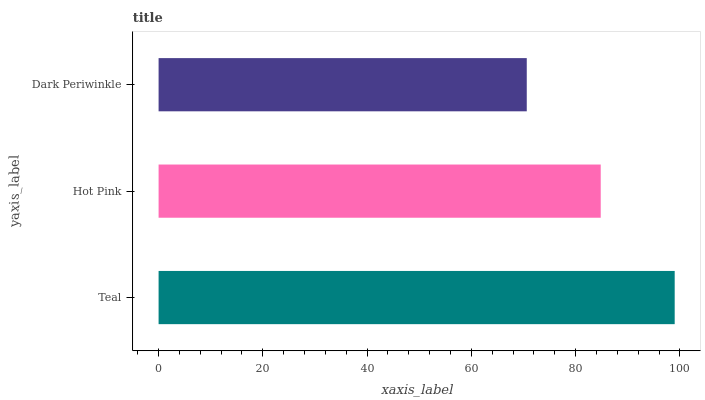Is Dark Periwinkle the minimum?
Answer yes or no. Yes. Is Teal the maximum?
Answer yes or no. Yes. Is Hot Pink the minimum?
Answer yes or no. No. Is Hot Pink the maximum?
Answer yes or no. No. Is Teal greater than Hot Pink?
Answer yes or no. Yes. Is Hot Pink less than Teal?
Answer yes or no. Yes. Is Hot Pink greater than Teal?
Answer yes or no. No. Is Teal less than Hot Pink?
Answer yes or no. No. Is Hot Pink the high median?
Answer yes or no. Yes. Is Hot Pink the low median?
Answer yes or no. Yes. Is Teal the high median?
Answer yes or no. No. Is Dark Periwinkle the low median?
Answer yes or no. No. 